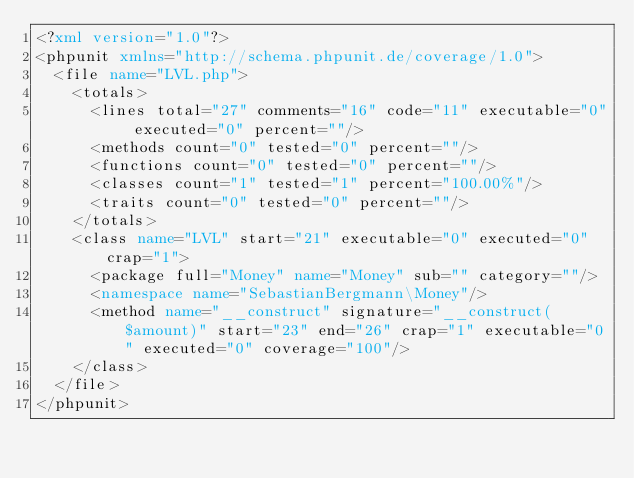Convert code to text. <code><loc_0><loc_0><loc_500><loc_500><_XML_><?xml version="1.0"?>
<phpunit xmlns="http://schema.phpunit.de/coverage/1.0">
  <file name="LVL.php">
    <totals>
      <lines total="27" comments="16" code="11" executable="0" executed="0" percent=""/>
      <methods count="0" tested="0" percent=""/>
      <functions count="0" tested="0" percent=""/>
      <classes count="1" tested="1" percent="100.00%"/>
      <traits count="0" tested="0" percent=""/>
    </totals>
    <class name="LVL" start="21" executable="0" executed="0" crap="1">
      <package full="Money" name="Money" sub="" category=""/>
      <namespace name="SebastianBergmann\Money"/>
      <method name="__construct" signature="__construct($amount)" start="23" end="26" crap="1" executable="0" executed="0" coverage="100"/>
    </class>
  </file>
</phpunit>
</code> 